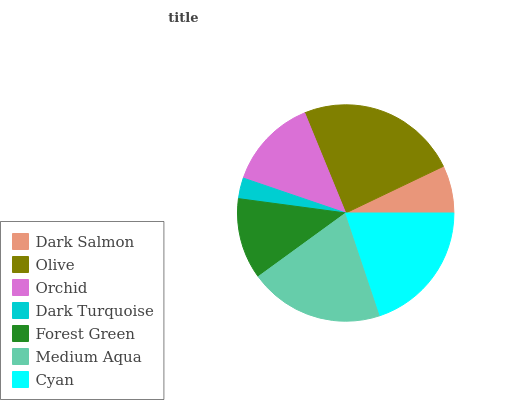Is Dark Turquoise the minimum?
Answer yes or no. Yes. Is Olive the maximum?
Answer yes or no. Yes. Is Orchid the minimum?
Answer yes or no. No. Is Orchid the maximum?
Answer yes or no. No. Is Olive greater than Orchid?
Answer yes or no. Yes. Is Orchid less than Olive?
Answer yes or no. Yes. Is Orchid greater than Olive?
Answer yes or no. No. Is Olive less than Orchid?
Answer yes or no. No. Is Orchid the high median?
Answer yes or no. Yes. Is Orchid the low median?
Answer yes or no. Yes. Is Medium Aqua the high median?
Answer yes or no. No. Is Olive the low median?
Answer yes or no. No. 